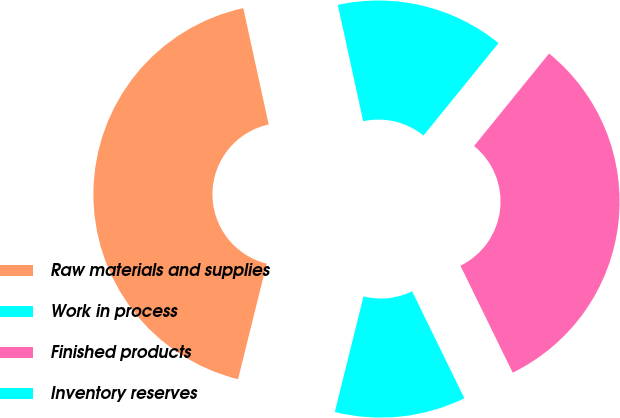Convert chart to OTSL. <chart><loc_0><loc_0><loc_500><loc_500><pie_chart><fcel>Raw materials and supplies<fcel>Work in process<fcel>Finished products<fcel>Inventory reserves<nl><fcel>42.71%<fcel>11.11%<fcel>31.92%<fcel>14.27%<nl></chart> 